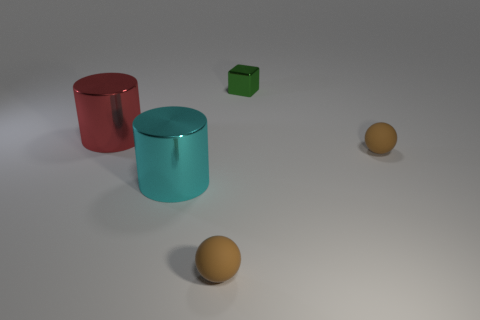What number of other things are there of the same shape as the green shiny object? There are no other items with the same exact shape as the green cube in the image. We can observe one red cylinder, one teal cylinder, and two spheres, all of which have different shapes than the green cube. 